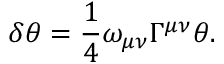Convert formula to latex. <formula><loc_0><loc_0><loc_500><loc_500>\delta \theta = \frac { 1 } { 4 } \omega _ { \mu \nu } \Gamma ^ { \mu \nu } \theta .</formula> 